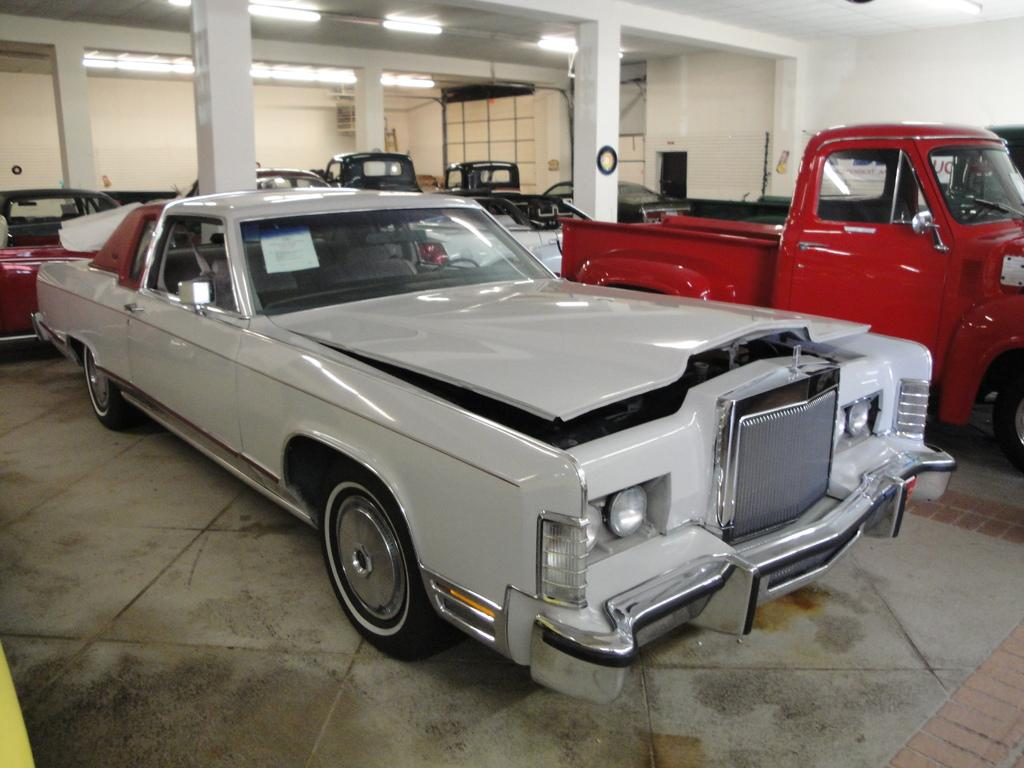What is the main subject in the foreground of the image? There is a hall in the foreground of the image. What can be seen inside the hall? Several motor vehicles are placed in the hall. What architectural features are visible in the background of the image? There are pillars, a wall, and lights in the background of the image. What part of the building is visible in the background of the image? The ceiling is visible in the background of the image. What type of music can be heard coming from the vehicles in the image? There is no indication of music or sound in the image, as it only shows motor vehicles placed in a hall. --- Facts: 1. There is a person sitting on a chair in the image. 2. The person is holding a book. 3. There is a table next to the chair. 4. There is a lamp on the table. 5. The background of the image is dark. Absurd Topics: parrot, ocean, dance Conversation: What is the person in the image doing? The person is sitting on a chair in the image. What object is the person holding? The person is holding a book. What is located next to the chair? There is a table next to the chair. What is on the table? There is a lamp on the table. What can be seen in the background of the image? The background of the image is dark. Reasoning: Let's think step by step in order to produce the conversation. We start by identifying the main subject in the image, which is the person sitting on a chair. Then, we describe the object the person is holding, which is a book. Next, we mention the table and lamp, which are located next to the chair. Finally, we describe the background, which is dark. Absurd Question/Answer: Can you see a parrot flying over the ocean in the image? There is no parrot or ocean present in the image; it only shows a person sitting on a chair holding a book. --- Facts: 1. There is a person standing on a bridge in the image. 2. The person is holding a camera. 3. There is a river below the bridge. 4. There are trees on both sides of the river. 5. The sky is visible in the image. Absurd Topics: fireworks, dinosaur, rainbow Conversation: What is the person in the image doing? The person is standing on a bridge in the image. What object is the person holding? The person is holding a camera. What can be seen below the bridge? There is a river below the bridge. What type of vegetation is present on both sides of the river? There are trees on both sides of the river 